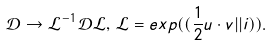<formula> <loc_0><loc_0><loc_500><loc_500>\mathcal { D } \rightarrow \mathcal { L } ^ { - 1 } \mathcal { D } \mathcal { L } , \, \mathcal { L } = e x p ( ( \frac { 1 } { 2 } u \cdot v | | i ) ) .</formula> 